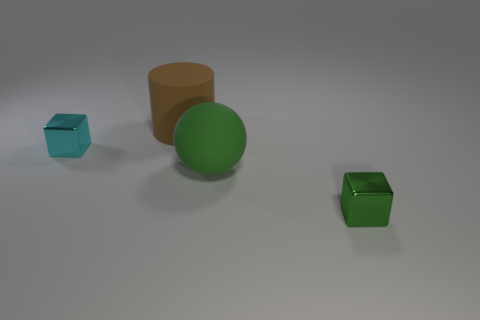What can you tell me about the lighting in this scene? The lighting appears to be diffused with soft shadows, suggesting an overhead light source not visible in the image. The lack of harsh shadows indicates that the light source is quite broad, providing an even illumination on the objects. 